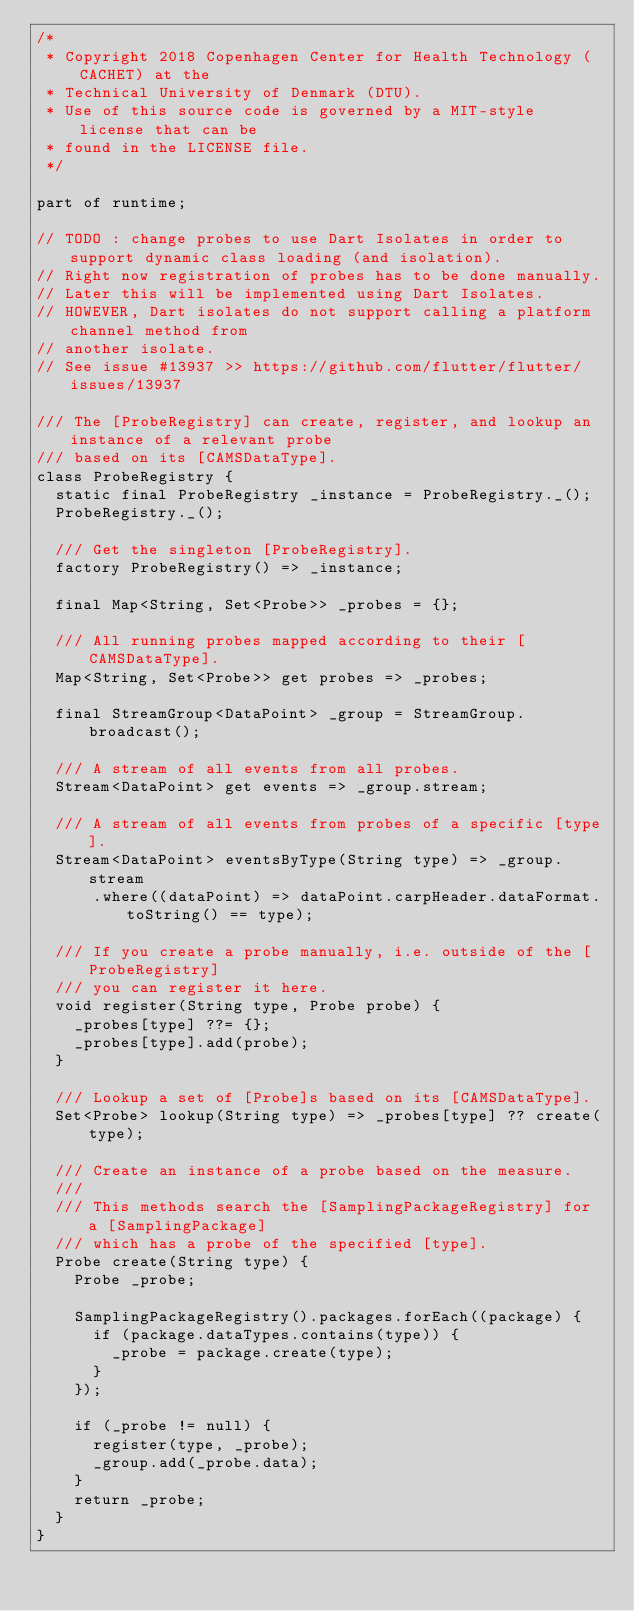<code> <loc_0><loc_0><loc_500><loc_500><_Dart_>/*
 * Copyright 2018 Copenhagen Center for Health Technology (CACHET) at the
 * Technical University of Denmark (DTU).
 * Use of this source code is governed by a MIT-style license that can be
 * found in the LICENSE file.
 */

part of runtime;

// TODO : change probes to use Dart Isolates in order to support dynamic class loading (and isolation).
// Right now registration of probes has to be done manually.
// Later this will be implemented using Dart Isolates.
// HOWEVER, Dart isolates do not support calling a platform channel method from
// another isolate.
// See issue #13937 >> https://github.com/flutter/flutter/issues/13937

/// The [ProbeRegistry] can create, register, and lookup an instance of a relevant probe
/// based on its [CAMSDataType].
class ProbeRegistry {
  static final ProbeRegistry _instance = ProbeRegistry._();
  ProbeRegistry._();

  /// Get the singleton [ProbeRegistry].
  factory ProbeRegistry() => _instance;

  final Map<String, Set<Probe>> _probes = {};

  /// All running probes mapped according to their [CAMSDataType].
  Map<String, Set<Probe>> get probes => _probes;

  final StreamGroup<DataPoint> _group = StreamGroup.broadcast();

  /// A stream of all events from all probes.
  Stream<DataPoint> get events => _group.stream;

  /// A stream of all events from probes of a specific [type].
  Stream<DataPoint> eventsByType(String type) => _group.stream
      .where((dataPoint) => dataPoint.carpHeader.dataFormat.toString() == type);

  /// If you create a probe manually, i.e. outside of the [ProbeRegistry]
  /// you can register it here.
  void register(String type, Probe probe) {
    _probes[type] ??= {};
    _probes[type].add(probe);
  }

  /// Lookup a set of [Probe]s based on its [CAMSDataType].
  Set<Probe> lookup(String type) => _probes[type] ?? create(type);

  /// Create an instance of a probe based on the measure.
  ///
  /// This methods search the [SamplingPackageRegistry] for a [SamplingPackage]
  /// which has a probe of the specified [type].
  Probe create(String type) {
    Probe _probe;

    SamplingPackageRegistry().packages.forEach((package) {
      if (package.dataTypes.contains(type)) {
        _probe = package.create(type);
      }
    });

    if (_probe != null) {
      register(type, _probe);
      _group.add(_probe.data);
    }
    return _probe;
  }
}
</code> 